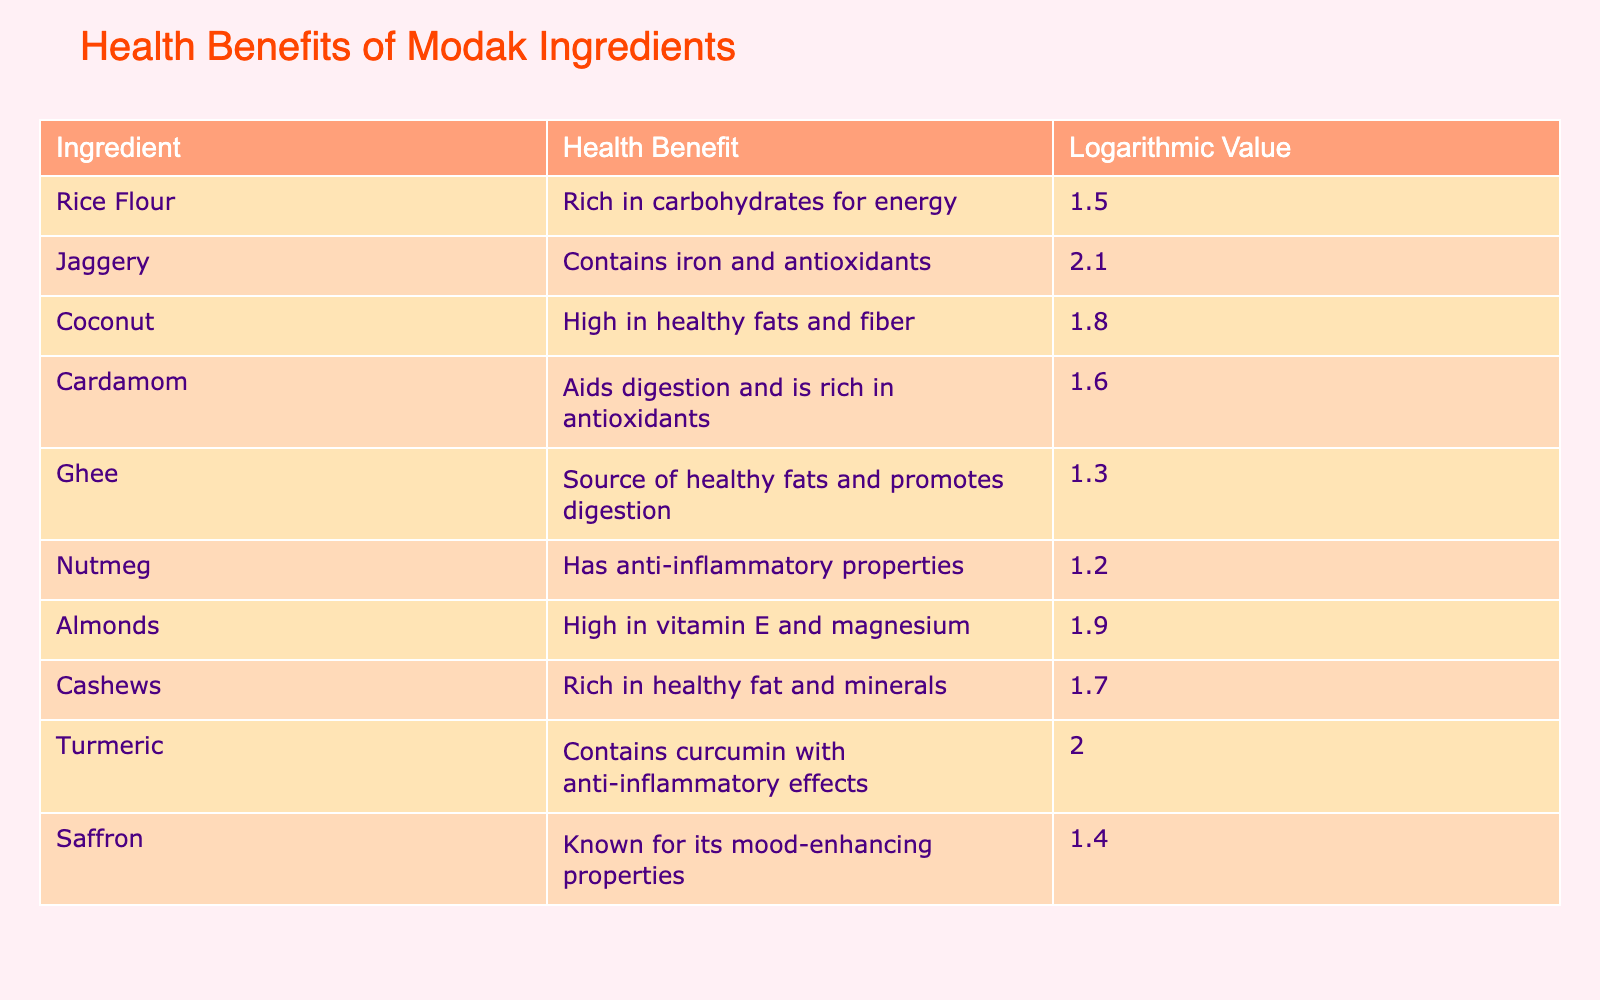What is the health benefit of Jaggery? According to the table, Jaggery is listed as containing iron and antioxidants. Therefore, the health benefit associated with Jaggery is its content of iron and antioxidants.
Answer: Contains iron and antioxidants Which ingredient is highest in healthy fats? The ingredient with the highest logarithmic value related to healthy fats is Coconut (1.8) and Cashews (1.7). Therefore, they are among the highest in healthy fats. Both ingredients emphasize the healthy fat content.
Answer: Coconut and Cashews What is the average logarithmic value for all ingredients? To find the average, we sum all logarithmic values: 1.5 + 2.1 + 1.8 + 1.6 + 1.3 + 1.2 + 1.9 + 1.7 + 2.0 + 1.4 = 16.1. There are 10 ingredients, so the average is 16.1 / 10 = 1.61.
Answer: 1.61 Do any ingredients in the table aid digestion? According to the table, both Cardamom and Ghee are noted for aiding digestion. Therefore, the answer is yes, there are ingredients that aid digestion.
Answer: Yes Which ingredient has anti-inflammatory properties? The table lists Nutmeg as having anti-inflammatory properties. Therefore, we can conclude that Nutmeg is associated with anti-inflammatory properties according to the data in the table.
Answer: Nutmeg What is the total health benefit of ingredients rich in vitamins? The ingredients that are rich in vitamins from the table are Almonds (Vitamin E) and Jaggery (iron). The total is just focusing on these two: vitamins are not summed but mentioned. Therefore, the conclusion is based on their notable content.
Answer: Almonds and Jaggery Is Saffron known for its mood-enhancing properties? The table provides information indicating that Saffron is indeed known for its mood-enhancing properties. Therefore, based on the table, we can answer yes.
Answer: Yes List all ingredients that contain antioxidants. The ingredients mentioned in the table that contain antioxidants are Jaggery and Cardamom. This identification is directly derived from the health benefits listed.
Answer: Jaggery and Cardamom 